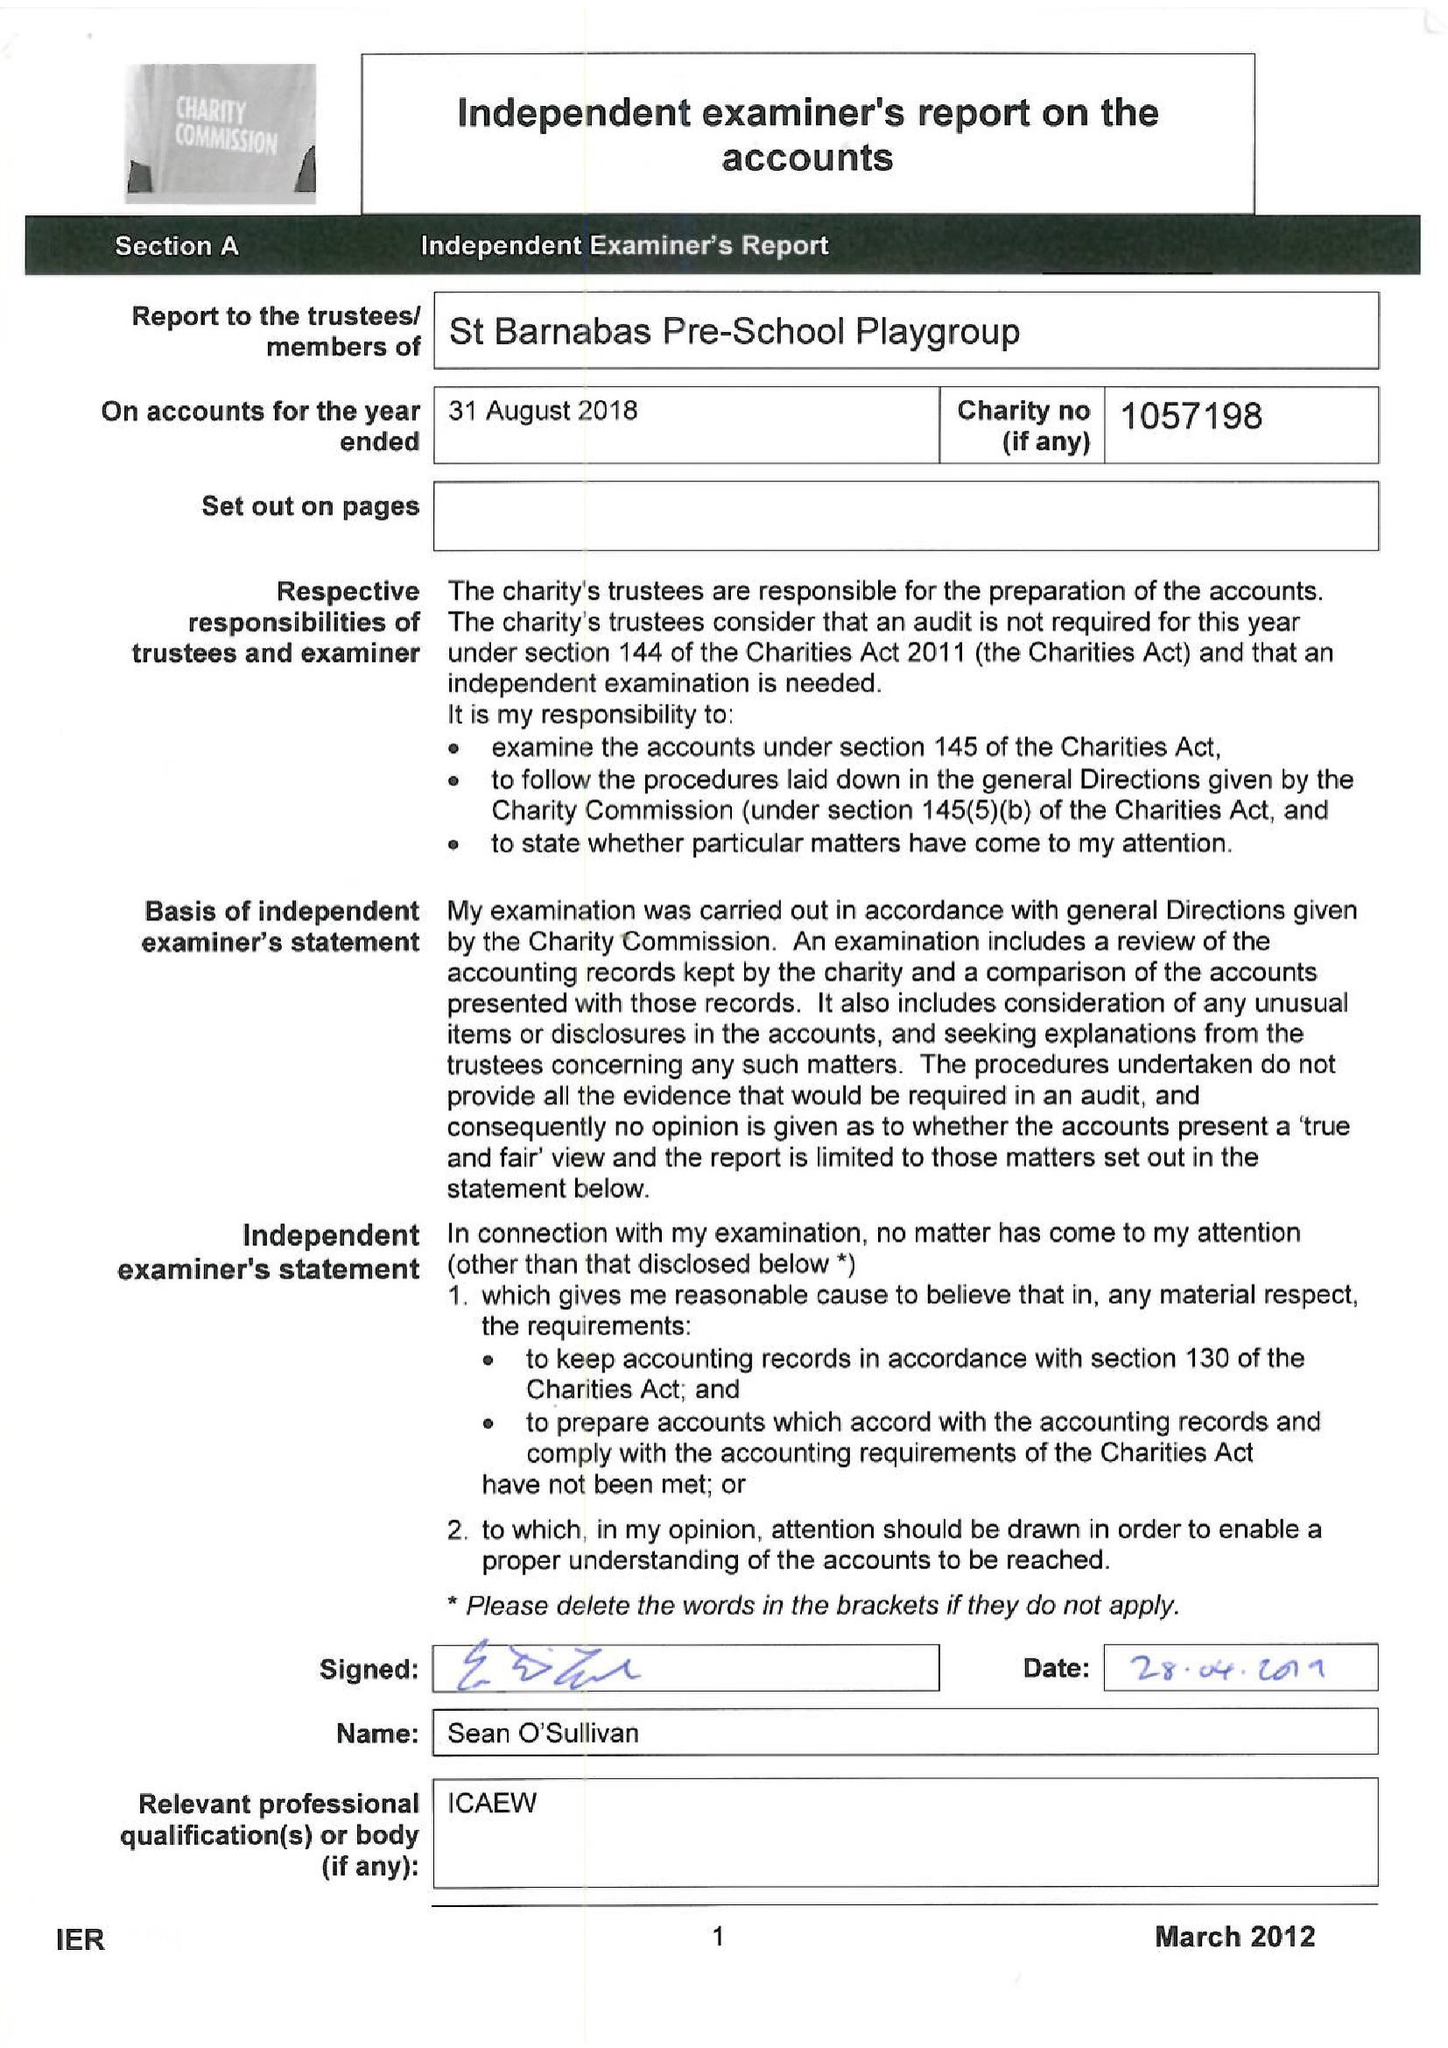What is the value for the address__street_line?
Answer the question using a single word or phrase. PITSHANGER LANE 